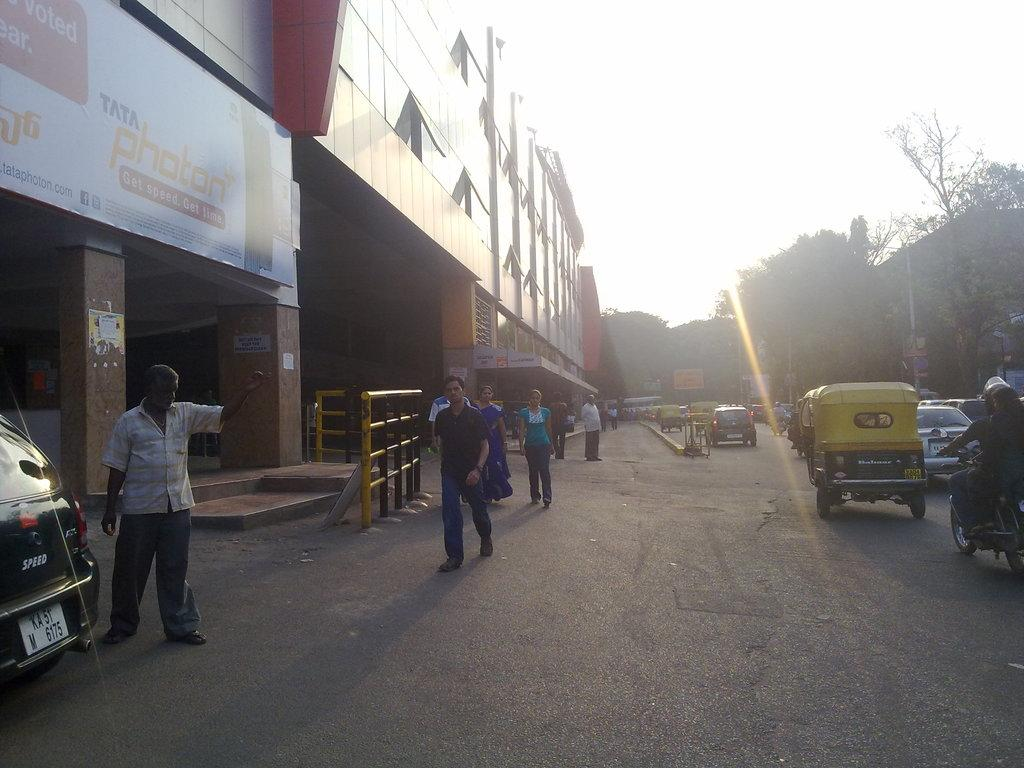How many people are in the image? There are people in the image, but the exact number is not specified. What types of vehicles are in the image? There are vehicles in the image, but the specific types are not mentioned. What are the poles used for in the image? The purpose of the poles is not clear from the facts provided. What are the boards used for in the image? The purpose of the boards is not clear from the facts provided. What is the fence used for in the image? The fence is likely used to mark boundaries or provide security, but the specific purpose is not mentioned. What is the road used for in the image? The road is likely used for transportation, but the specific use is not mentioned. What type of vegetation is visible in the background of the image? Trees are visible in the background of the image. What type of structures are visible in the background of the image? Buildings are visible in the background of the image. What is visible at the top of the image? The sky is visible at the top of the image. How do the people in the image plan their vacation? There is no information about vacations or planning in the image. Can you tell me how the boats sail in the image? There is no mention of boats or sailing in the image. 